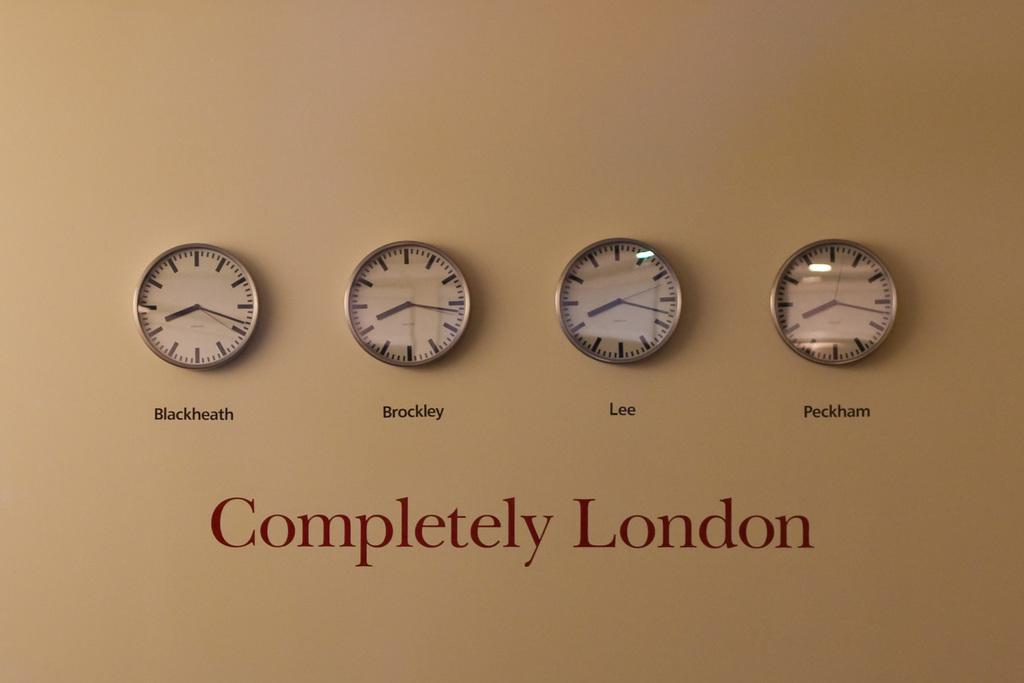What is written or displayed on the wall in the image? There is text on the wall in the image. What else can be seen on the wall besides the text? There are clocks on the wall in the image. What type of amusement can be seen in the image? There is no amusement present in the image; it only features text and clocks on the wall. Is there any indication of pain or suffering in the image? There is no indication of pain or suffering in the image; it only features text and clocks on the wall. 